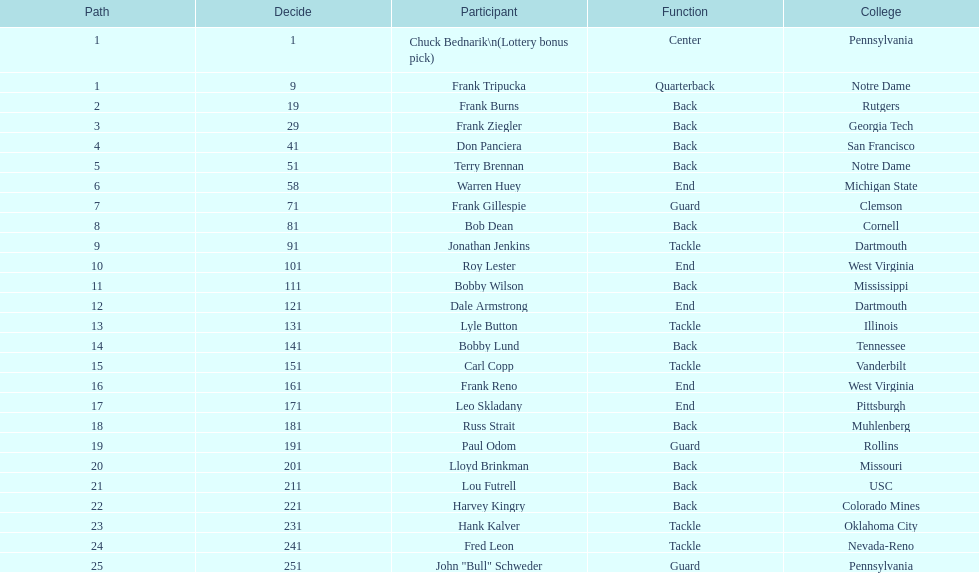Who was chosen after frank burns? Frank Ziegler. 